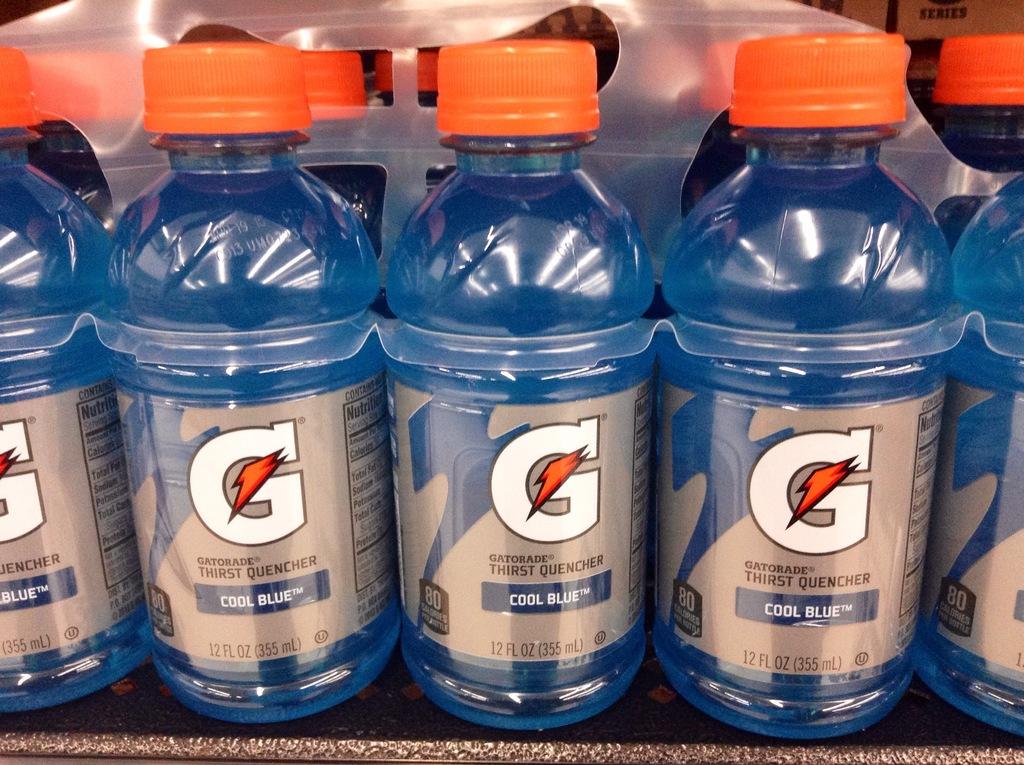What is in the bottles?
Provide a succinct answer. Gatorade. 